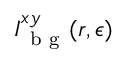Convert formula to latex. <formula><loc_0><loc_0><loc_500><loc_500>I _ { b g } ^ { x y } ( r , \epsilon )</formula> 